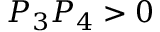<formula> <loc_0><loc_0><loc_500><loc_500>P _ { 3 } P _ { 4 } > 0</formula> 